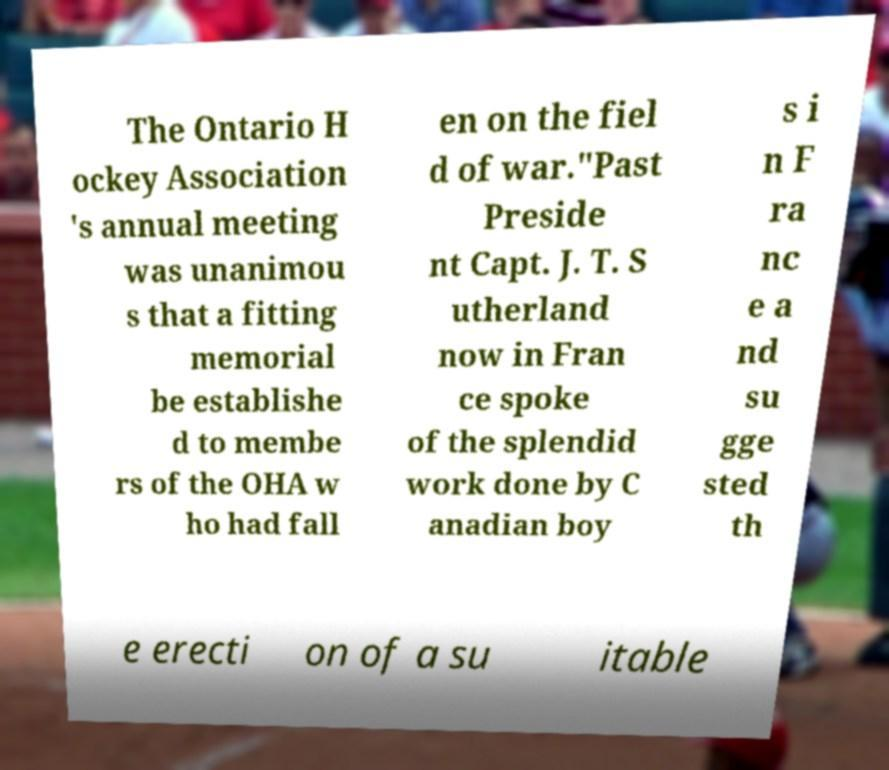I need the written content from this picture converted into text. Can you do that? The Ontario H ockey Association 's annual meeting was unanimou s that a fitting memorial be establishe d to membe rs of the OHA w ho had fall en on the fiel d of war."Past Preside nt Capt. J. T. S utherland now in Fran ce spoke of the splendid work done by C anadian boy s i n F ra nc e a nd su gge sted th e erecti on of a su itable 